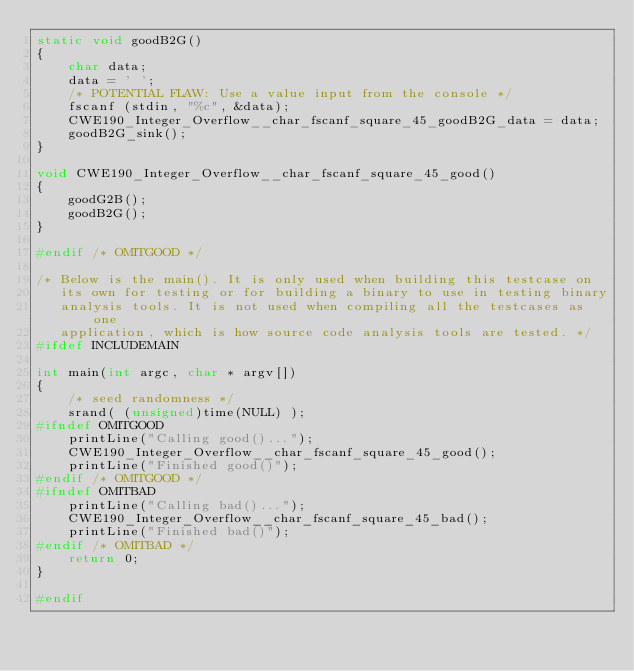Convert code to text. <code><loc_0><loc_0><loc_500><loc_500><_C_>static void goodB2G()
{
    char data;
    data = ' ';
    /* POTENTIAL FLAW: Use a value input from the console */
    fscanf (stdin, "%c", &data);
    CWE190_Integer_Overflow__char_fscanf_square_45_goodB2G_data = data;
    goodB2G_sink();
}

void CWE190_Integer_Overflow__char_fscanf_square_45_good()
{
    goodG2B();
    goodB2G();
}

#endif /* OMITGOOD */

/* Below is the main(). It is only used when building this testcase on
   its own for testing or for building a binary to use in testing binary
   analysis tools. It is not used when compiling all the testcases as one
   application, which is how source code analysis tools are tested. */
#ifdef INCLUDEMAIN

int main(int argc, char * argv[])
{
    /* seed randomness */
    srand( (unsigned)time(NULL) );
#ifndef OMITGOOD
    printLine("Calling good()...");
    CWE190_Integer_Overflow__char_fscanf_square_45_good();
    printLine("Finished good()");
#endif /* OMITGOOD */
#ifndef OMITBAD
    printLine("Calling bad()...");
    CWE190_Integer_Overflow__char_fscanf_square_45_bad();
    printLine("Finished bad()");
#endif /* OMITBAD */
    return 0;
}

#endif
</code> 